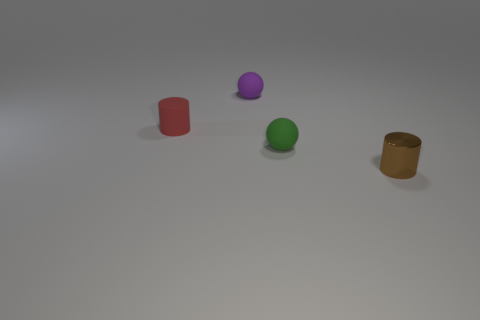Is there any other thing that has the same material as the brown thing?
Keep it short and to the point. No. What is the shape of the tiny matte object that is on the right side of the purple ball?
Your response must be concise. Sphere. What size is the cylinder behind the tiny cylinder that is in front of the cylinder that is to the left of the brown object?
Make the answer very short. Small. There is a small cylinder behind the shiny object; how many rubber objects are behind it?
Keep it short and to the point. 1. What size is the object that is both on the left side of the small metal cylinder and in front of the tiny rubber cylinder?
Ensure brevity in your answer.  Small. How many rubber things are big green cubes or small purple things?
Ensure brevity in your answer.  1. What material is the tiny green ball?
Ensure brevity in your answer.  Rubber. What is the ball that is in front of the matte ball behind the tiny cylinder behind the small green matte thing made of?
Provide a succinct answer. Rubber. What is the shape of the green object that is the same size as the brown metallic cylinder?
Your answer should be compact. Sphere. What number of things are red rubber things or tiny rubber objects behind the tiny red rubber cylinder?
Make the answer very short. 2. 